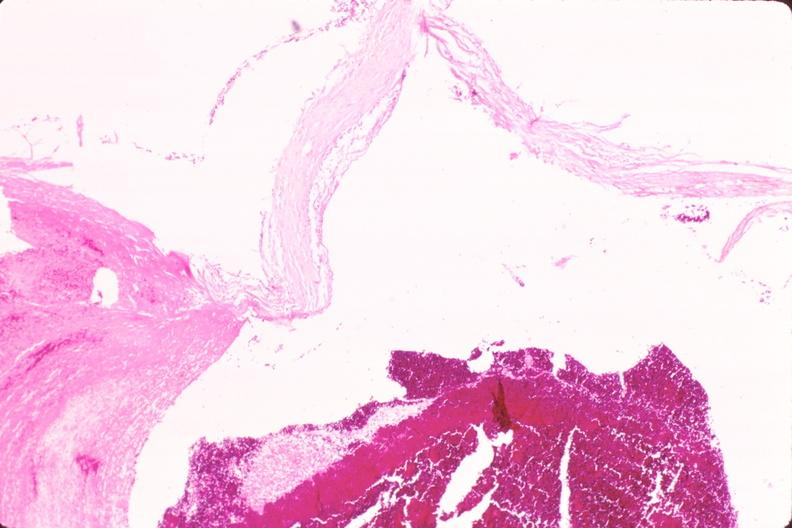does this image show ruptured saccular aneurysm right middle cerebral artery?
Answer the question using a single word or phrase. Yes 